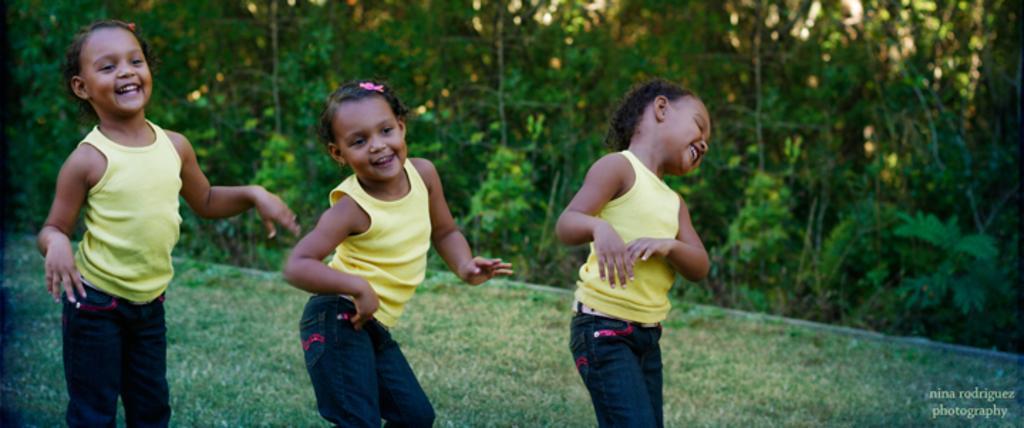Describe this image in one or two sentences. In this picture I can see 3 girls, who are standing in front and I see that they're smiling and they're wearing same dress. In the background I can see the grass and the trees. On the right bottom corner of this picture I can see the watermark. 